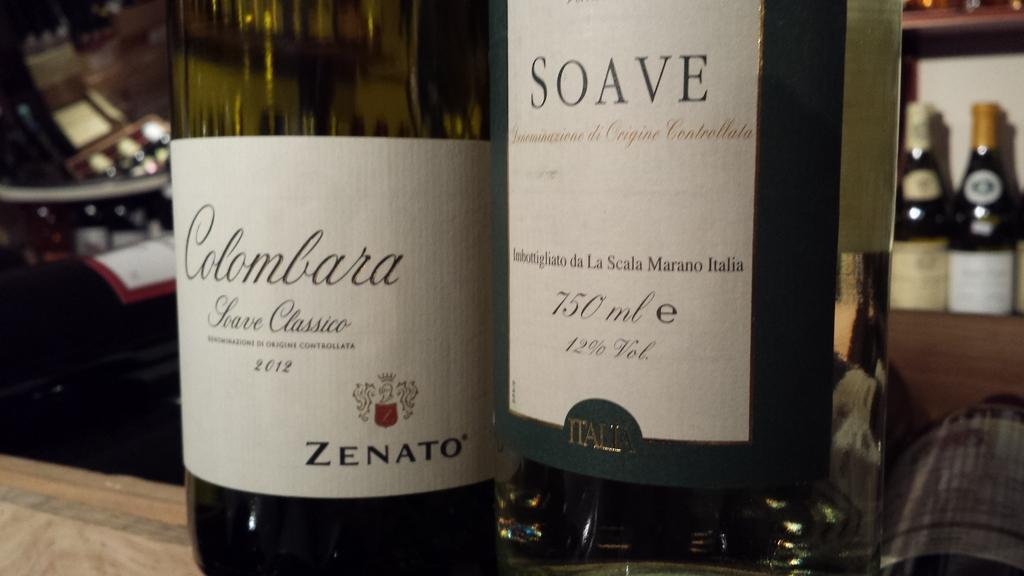<image>
Render a clear and concise summary of the photo. Two bottles of wine called Colombara and Soave sit on a counter. 